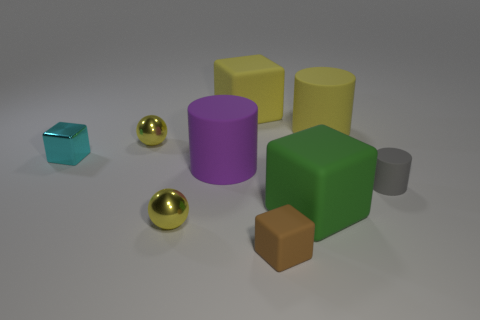Subtract all cyan blocks. How many blocks are left? 3 Subtract all green blocks. How many blocks are left? 3 Add 5 gray objects. How many gray objects are left? 6 Add 6 large blue matte cylinders. How many large blue matte cylinders exist? 6 Add 1 tiny purple matte cubes. How many objects exist? 10 Subtract 0 blue balls. How many objects are left? 9 Subtract all cylinders. How many objects are left? 6 Subtract 1 spheres. How many spheres are left? 1 Subtract all gray spheres. Subtract all blue cubes. How many spheres are left? 2 Subtract all blue blocks. How many purple cylinders are left? 1 